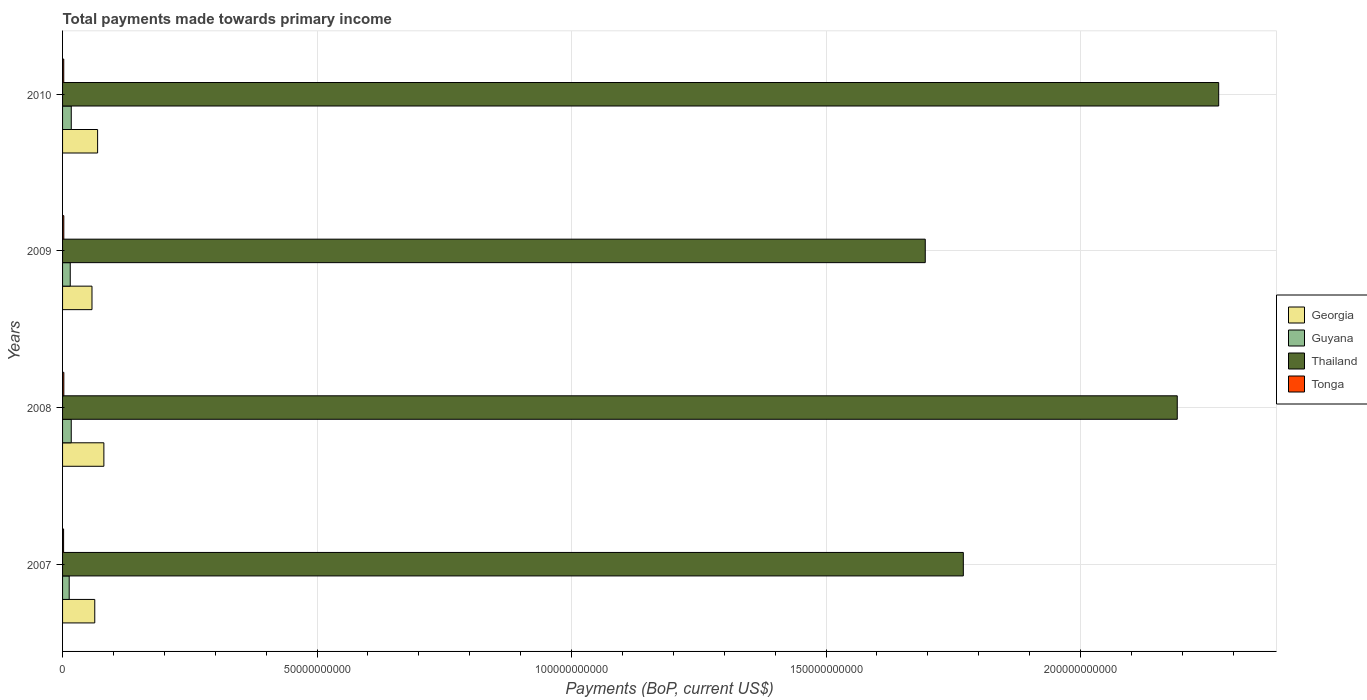How many different coloured bars are there?
Provide a short and direct response. 4. How many bars are there on the 1st tick from the top?
Make the answer very short. 4. How many bars are there on the 4th tick from the bottom?
Your response must be concise. 4. What is the label of the 4th group of bars from the top?
Give a very brief answer. 2007. What is the total payments made towards primary income in Tonga in 2010?
Your response must be concise. 2.33e+08. Across all years, what is the maximum total payments made towards primary income in Guyana?
Offer a very short reply. 1.71e+09. Across all years, what is the minimum total payments made towards primary income in Georgia?
Provide a short and direct response. 5.78e+09. What is the total total payments made towards primary income in Guyana in the graph?
Make the answer very short. 6.23e+09. What is the difference between the total payments made towards primary income in Georgia in 2007 and that in 2009?
Make the answer very short. 5.46e+08. What is the difference between the total payments made towards primary income in Guyana in 2009 and the total payments made towards primary income in Thailand in 2007?
Make the answer very short. -1.75e+11. What is the average total payments made towards primary income in Georgia per year?
Your answer should be compact. 6.78e+09. In the year 2009, what is the difference between the total payments made towards primary income in Guyana and total payments made towards primary income in Thailand?
Offer a terse response. -1.68e+11. In how many years, is the total payments made towards primary income in Thailand greater than 200000000000 US$?
Your answer should be compact. 2. What is the ratio of the total payments made towards primary income in Guyana in 2009 to that in 2010?
Ensure brevity in your answer.  0.88. What is the difference between the highest and the second highest total payments made towards primary income in Tonga?
Offer a very short reply. 5.78e+06. What is the difference between the highest and the lowest total payments made towards primary income in Guyana?
Offer a very short reply. 4.06e+08. What does the 1st bar from the top in 2007 represents?
Your answer should be compact. Tonga. What does the 1st bar from the bottom in 2009 represents?
Keep it short and to the point. Georgia. Is it the case that in every year, the sum of the total payments made towards primary income in Guyana and total payments made towards primary income in Tonga is greater than the total payments made towards primary income in Georgia?
Keep it short and to the point. No. How many bars are there?
Keep it short and to the point. 16. How many years are there in the graph?
Your response must be concise. 4. What is the difference between two consecutive major ticks on the X-axis?
Your response must be concise. 5.00e+1. Are the values on the major ticks of X-axis written in scientific E-notation?
Offer a very short reply. No. Does the graph contain any zero values?
Provide a succinct answer. No. Does the graph contain grids?
Your response must be concise. Yes. How many legend labels are there?
Your response must be concise. 4. How are the legend labels stacked?
Provide a succinct answer. Vertical. What is the title of the graph?
Make the answer very short. Total payments made towards primary income. What is the label or title of the X-axis?
Ensure brevity in your answer.  Payments (BoP, current US$). What is the label or title of the Y-axis?
Offer a very short reply. Years. What is the Payments (BoP, current US$) in Georgia in 2007?
Your answer should be very brief. 6.32e+09. What is the Payments (BoP, current US$) of Guyana in 2007?
Make the answer very short. 1.30e+09. What is the Payments (BoP, current US$) of Thailand in 2007?
Provide a short and direct response. 1.77e+11. What is the Payments (BoP, current US$) in Tonga in 2007?
Your answer should be very brief. 2.03e+08. What is the Payments (BoP, current US$) of Georgia in 2008?
Make the answer very short. 8.11e+09. What is the Payments (BoP, current US$) in Guyana in 2008?
Your response must be concise. 1.70e+09. What is the Payments (BoP, current US$) in Thailand in 2008?
Ensure brevity in your answer.  2.19e+11. What is the Payments (BoP, current US$) in Tonga in 2008?
Make the answer very short. 2.51e+08. What is the Payments (BoP, current US$) in Georgia in 2009?
Your response must be concise. 5.78e+09. What is the Payments (BoP, current US$) of Guyana in 2009?
Your response must be concise. 1.51e+09. What is the Payments (BoP, current US$) in Thailand in 2009?
Your answer should be compact. 1.69e+11. What is the Payments (BoP, current US$) of Tonga in 2009?
Ensure brevity in your answer.  2.45e+08. What is the Payments (BoP, current US$) of Georgia in 2010?
Your answer should be very brief. 6.89e+09. What is the Payments (BoP, current US$) in Guyana in 2010?
Make the answer very short. 1.71e+09. What is the Payments (BoP, current US$) in Thailand in 2010?
Ensure brevity in your answer.  2.27e+11. What is the Payments (BoP, current US$) of Tonga in 2010?
Keep it short and to the point. 2.33e+08. Across all years, what is the maximum Payments (BoP, current US$) of Georgia?
Your answer should be very brief. 8.11e+09. Across all years, what is the maximum Payments (BoP, current US$) in Guyana?
Offer a terse response. 1.71e+09. Across all years, what is the maximum Payments (BoP, current US$) of Thailand?
Offer a very short reply. 2.27e+11. Across all years, what is the maximum Payments (BoP, current US$) in Tonga?
Offer a very short reply. 2.51e+08. Across all years, what is the minimum Payments (BoP, current US$) in Georgia?
Give a very brief answer. 5.78e+09. Across all years, what is the minimum Payments (BoP, current US$) of Guyana?
Offer a very short reply. 1.30e+09. Across all years, what is the minimum Payments (BoP, current US$) of Thailand?
Make the answer very short. 1.69e+11. Across all years, what is the minimum Payments (BoP, current US$) of Tonga?
Your answer should be very brief. 2.03e+08. What is the total Payments (BoP, current US$) in Georgia in the graph?
Ensure brevity in your answer.  2.71e+1. What is the total Payments (BoP, current US$) in Guyana in the graph?
Give a very brief answer. 6.23e+09. What is the total Payments (BoP, current US$) of Thailand in the graph?
Make the answer very short. 7.93e+11. What is the total Payments (BoP, current US$) of Tonga in the graph?
Your response must be concise. 9.32e+08. What is the difference between the Payments (BoP, current US$) in Georgia in 2007 and that in 2008?
Give a very brief answer. -1.79e+09. What is the difference between the Payments (BoP, current US$) of Guyana in 2007 and that in 2008?
Your response must be concise. -4.02e+08. What is the difference between the Payments (BoP, current US$) in Thailand in 2007 and that in 2008?
Provide a short and direct response. -4.20e+1. What is the difference between the Payments (BoP, current US$) of Tonga in 2007 and that in 2008?
Provide a succinct answer. -4.80e+07. What is the difference between the Payments (BoP, current US$) of Georgia in 2007 and that in 2009?
Give a very brief answer. 5.46e+08. What is the difference between the Payments (BoP, current US$) of Guyana in 2007 and that in 2009?
Keep it short and to the point. -2.05e+08. What is the difference between the Payments (BoP, current US$) of Thailand in 2007 and that in 2009?
Ensure brevity in your answer.  7.48e+09. What is the difference between the Payments (BoP, current US$) of Tonga in 2007 and that in 2009?
Keep it short and to the point. -4.23e+07. What is the difference between the Payments (BoP, current US$) of Georgia in 2007 and that in 2010?
Keep it short and to the point. -5.60e+08. What is the difference between the Payments (BoP, current US$) of Guyana in 2007 and that in 2010?
Give a very brief answer. -4.06e+08. What is the difference between the Payments (BoP, current US$) of Thailand in 2007 and that in 2010?
Ensure brevity in your answer.  -5.02e+1. What is the difference between the Payments (BoP, current US$) in Tonga in 2007 and that in 2010?
Provide a succinct answer. -2.95e+07. What is the difference between the Payments (BoP, current US$) of Georgia in 2008 and that in 2009?
Your response must be concise. 2.34e+09. What is the difference between the Payments (BoP, current US$) in Guyana in 2008 and that in 2009?
Your answer should be very brief. 1.96e+08. What is the difference between the Payments (BoP, current US$) in Thailand in 2008 and that in 2009?
Provide a short and direct response. 4.95e+1. What is the difference between the Payments (BoP, current US$) of Tonga in 2008 and that in 2009?
Offer a terse response. 5.78e+06. What is the difference between the Payments (BoP, current US$) of Georgia in 2008 and that in 2010?
Keep it short and to the point. 1.23e+09. What is the difference between the Payments (BoP, current US$) in Guyana in 2008 and that in 2010?
Offer a very short reply. -3.92e+06. What is the difference between the Payments (BoP, current US$) in Thailand in 2008 and that in 2010?
Your response must be concise. -8.14e+09. What is the difference between the Payments (BoP, current US$) in Tonga in 2008 and that in 2010?
Your response must be concise. 1.86e+07. What is the difference between the Payments (BoP, current US$) of Georgia in 2009 and that in 2010?
Keep it short and to the point. -1.11e+09. What is the difference between the Payments (BoP, current US$) of Guyana in 2009 and that in 2010?
Provide a short and direct response. -2.00e+08. What is the difference between the Payments (BoP, current US$) of Thailand in 2009 and that in 2010?
Provide a short and direct response. -5.76e+1. What is the difference between the Payments (BoP, current US$) in Tonga in 2009 and that in 2010?
Your response must be concise. 1.28e+07. What is the difference between the Payments (BoP, current US$) of Georgia in 2007 and the Payments (BoP, current US$) of Guyana in 2008?
Offer a terse response. 4.62e+09. What is the difference between the Payments (BoP, current US$) in Georgia in 2007 and the Payments (BoP, current US$) in Thailand in 2008?
Your answer should be very brief. -2.13e+11. What is the difference between the Payments (BoP, current US$) in Georgia in 2007 and the Payments (BoP, current US$) in Tonga in 2008?
Give a very brief answer. 6.07e+09. What is the difference between the Payments (BoP, current US$) of Guyana in 2007 and the Payments (BoP, current US$) of Thailand in 2008?
Your response must be concise. -2.18e+11. What is the difference between the Payments (BoP, current US$) in Guyana in 2007 and the Payments (BoP, current US$) in Tonga in 2008?
Provide a succinct answer. 1.05e+09. What is the difference between the Payments (BoP, current US$) of Thailand in 2007 and the Payments (BoP, current US$) of Tonga in 2008?
Offer a terse response. 1.77e+11. What is the difference between the Payments (BoP, current US$) of Georgia in 2007 and the Payments (BoP, current US$) of Guyana in 2009?
Ensure brevity in your answer.  4.82e+09. What is the difference between the Payments (BoP, current US$) in Georgia in 2007 and the Payments (BoP, current US$) in Thailand in 2009?
Provide a short and direct response. -1.63e+11. What is the difference between the Payments (BoP, current US$) of Georgia in 2007 and the Payments (BoP, current US$) of Tonga in 2009?
Your answer should be very brief. 6.08e+09. What is the difference between the Payments (BoP, current US$) in Guyana in 2007 and the Payments (BoP, current US$) in Thailand in 2009?
Offer a very short reply. -1.68e+11. What is the difference between the Payments (BoP, current US$) in Guyana in 2007 and the Payments (BoP, current US$) in Tonga in 2009?
Your answer should be very brief. 1.06e+09. What is the difference between the Payments (BoP, current US$) in Thailand in 2007 and the Payments (BoP, current US$) in Tonga in 2009?
Make the answer very short. 1.77e+11. What is the difference between the Payments (BoP, current US$) of Georgia in 2007 and the Payments (BoP, current US$) of Guyana in 2010?
Ensure brevity in your answer.  4.62e+09. What is the difference between the Payments (BoP, current US$) of Georgia in 2007 and the Payments (BoP, current US$) of Thailand in 2010?
Make the answer very short. -2.21e+11. What is the difference between the Payments (BoP, current US$) in Georgia in 2007 and the Payments (BoP, current US$) in Tonga in 2010?
Provide a succinct answer. 6.09e+09. What is the difference between the Payments (BoP, current US$) of Guyana in 2007 and the Payments (BoP, current US$) of Thailand in 2010?
Offer a terse response. -2.26e+11. What is the difference between the Payments (BoP, current US$) of Guyana in 2007 and the Payments (BoP, current US$) of Tonga in 2010?
Make the answer very short. 1.07e+09. What is the difference between the Payments (BoP, current US$) of Thailand in 2007 and the Payments (BoP, current US$) of Tonga in 2010?
Provide a succinct answer. 1.77e+11. What is the difference between the Payments (BoP, current US$) in Georgia in 2008 and the Payments (BoP, current US$) in Guyana in 2009?
Provide a short and direct response. 6.61e+09. What is the difference between the Payments (BoP, current US$) of Georgia in 2008 and the Payments (BoP, current US$) of Thailand in 2009?
Offer a terse response. -1.61e+11. What is the difference between the Payments (BoP, current US$) of Georgia in 2008 and the Payments (BoP, current US$) of Tonga in 2009?
Ensure brevity in your answer.  7.87e+09. What is the difference between the Payments (BoP, current US$) in Guyana in 2008 and the Payments (BoP, current US$) in Thailand in 2009?
Keep it short and to the point. -1.68e+11. What is the difference between the Payments (BoP, current US$) in Guyana in 2008 and the Payments (BoP, current US$) in Tonga in 2009?
Give a very brief answer. 1.46e+09. What is the difference between the Payments (BoP, current US$) of Thailand in 2008 and the Payments (BoP, current US$) of Tonga in 2009?
Offer a very short reply. 2.19e+11. What is the difference between the Payments (BoP, current US$) in Georgia in 2008 and the Payments (BoP, current US$) in Guyana in 2010?
Your answer should be very brief. 6.41e+09. What is the difference between the Payments (BoP, current US$) of Georgia in 2008 and the Payments (BoP, current US$) of Thailand in 2010?
Provide a short and direct response. -2.19e+11. What is the difference between the Payments (BoP, current US$) of Georgia in 2008 and the Payments (BoP, current US$) of Tonga in 2010?
Your answer should be very brief. 7.88e+09. What is the difference between the Payments (BoP, current US$) in Guyana in 2008 and the Payments (BoP, current US$) in Thailand in 2010?
Keep it short and to the point. -2.25e+11. What is the difference between the Payments (BoP, current US$) of Guyana in 2008 and the Payments (BoP, current US$) of Tonga in 2010?
Provide a short and direct response. 1.47e+09. What is the difference between the Payments (BoP, current US$) of Thailand in 2008 and the Payments (BoP, current US$) of Tonga in 2010?
Ensure brevity in your answer.  2.19e+11. What is the difference between the Payments (BoP, current US$) of Georgia in 2009 and the Payments (BoP, current US$) of Guyana in 2010?
Offer a terse response. 4.07e+09. What is the difference between the Payments (BoP, current US$) of Georgia in 2009 and the Payments (BoP, current US$) of Thailand in 2010?
Provide a short and direct response. -2.21e+11. What is the difference between the Payments (BoP, current US$) in Georgia in 2009 and the Payments (BoP, current US$) in Tonga in 2010?
Offer a very short reply. 5.55e+09. What is the difference between the Payments (BoP, current US$) in Guyana in 2009 and the Payments (BoP, current US$) in Thailand in 2010?
Make the answer very short. -2.26e+11. What is the difference between the Payments (BoP, current US$) in Guyana in 2009 and the Payments (BoP, current US$) in Tonga in 2010?
Your answer should be very brief. 1.28e+09. What is the difference between the Payments (BoP, current US$) of Thailand in 2009 and the Payments (BoP, current US$) of Tonga in 2010?
Make the answer very short. 1.69e+11. What is the average Payments (BoP, current US$) of Georgia per year?
Your answer should be compact. 6.78e+09. What is the average Payments (BoP, current US$) of Guyana per year?
Provide a short and direct response. 1.56e+09. What is the average Payments (BoP, current US$) of Thailand per year?
Provide a short and direct response. 1.98e+11. What is the average Payments (BoP, current US$) in Tonga per year?
Your answer should be compact. 2.33e+08. In the year 2007, what is the difference between the Payments (BoP, current US$) of Georgia and Payments (BoP, current US$) of Guyana?
Your response must be concise. 5.02e+09. In the year 2007, what is the difference between the Payments (BoP, current US$) of Georgia and Payments (BoP, current US$) of Thailand?
Make the answer very short. -1.71e+11. In the year 2007, what is the difference between the Payments (BoP, current US$) of Georgia and Payments (BoP, current US$) of Tonga?
Ensure brevity in your answer.  6.12e+09. In the year 2007, what is the difference between the Payments (BoP, current US$) in Guyana and Payments (BoP, current US$) in Thailand?
Provide a succinct answer. -1.76e+11. In the year 2007, what is the difference between the Payments (BoP, current US$) in Guyana and Payments (BoP, current US$) in Tonga?
Your response must be concise. 1.10e+09. In the year 2007, what is the difference between the Payments (BoP, current US$) of Thailand and Payments (BoP, current US$) of Tonga?
Your response must be concise. 1.77e+11. In the year 2008, what is the difference between the Payments (BoP, current US$) of Georgia and Payments (BoP, current US$) of Guyana?
Ensure brevity in your answer.  6.41e+09. In the year 2008, what is the difference between the Payments (BoP, current US$) of Georgia and Payments (BoP, current US$) of Thailand?
Your answer should be compact. -2.11e+11. In the year 2008, what is the difference between the Payments (BoP, current US$) in Georgia and Payments (BoP, current US$) in Tonga?
Your response must be concise. 7.86e+09. In the year 2008, what is the difference between the Payments (BoP, current US$) of Guyana and Payments (BoP, current US$) of Thailand?
Provide a succinct answer. -2.17e+11. In the year 2008, what is the difference between the Payments (BoP, current US$) of Guyana and Payments (BoP, current US$) of Tonga?
Provide a short and direct response. 1.45e+09. In the year 2008, what is the difference between the Payments (BoP, current US$) in Thailand and Payments (BoP, current US$) in Tonga?
Offer a terse response. 2.19e+11. In the year 2009, what is the difference between the Payments (BoP, current US$) of Georgia and Payments (BoP, current US$) of Guyana?
Your response must be concise. 4.27e+09. In the year 2009, what is the difference between the Payments (BoP, current US$) in Georgia and Payments (BoP, current US$) in Thailand?
Your response must be concise. -1.64e+11. In the year 2009, what is the difference between the Payments (BoP, current US$) of Georgia and Payments (BoP, current US$) of Tonga?
Your response must be concise. 5.53e+09. In the year 2009, what is the difference between the Payments (BoP, current US$) of Guyana and Payments (BoP, current US$) of Thailand?
Offer a terse response. -1.68e+11. In the year 2009, what is the difference between the Payments (BoP, current US$) in Guyana and Payments (BoP, current US$) in Tonga?
Your response must be concise. 1.26e+09. In the year 2009, what is the difference between the Payments (BoP, current US$) in Thailand and Payments (BoP, current US$) in Tonga?
Provide a short and direct response. 1.69e+11. In the year 2010, what is the difference between the Payments (BoP, current US$) in Georgia and Payments (BoP, current US$) in Guyana?
Keep it short and to the point. 5.18e+09. In the year 2010, what is the difference between the Payments (BoP, current US$) of Georgia and Payments (BoP, current US$) of Thailand?
Ensure brevity in your answer.  -2.20e+11. In the year 2010, what is the difference between the Payments (BoP, current US$) of Georgia and Payments (BoP, current US$) of Tonga?
Provide a short and direct response. 6.65e+09. In the year 2010, what is the difference between the Payments (BoP, current US$) of Guyana and Payments (BoP, current US$) of Thailand?
Make the answer very short. -2.25e+11. In the year 2010, what is the difference between the Payments (BoP, current US$) of Guyana and Payments (BoP, current US$) of Tonga?
Offer a terse response. 1.48e+09. In the year 2010, what is the difference between the Payments (BoP, current US$) of Thailand and Payments (BoP, current US$) of Tonga?
Your response must be concise. 2.27e+11. What is the ratio of the Payments (BoP, current US$) of Georgia in 2007 to that in 2008?
Offer a very short reply. 0.78. What is the ratio of the Payments (BoP, current US$) in Guyana in 2007 to that in 2008?
Your answer should be very brief. 0.76. What is the ratio of the Payments (BoP, current US$) of Thailand in 2007 to that in 2008?
Offer a very short reply. 0.81. What is the ratio of the Payments (BoP, current US$) of Tonga in 2007 to that in 2008?
Your answer should be very brief. 0.81. What is the ratio of the Payments (BoP, current US$) in Georgia in 2007 to that in 2009?
Offer a terse response. 1.09. What is the ratio of the Payments (BoP, current US$) of Guyana in 2007 to that in 2009?
Offer a terse response. 0.86. What is the ratio of the Payments (BoP, current US$) in Thailand in 2007 to that in 2009?
Keep it short and to the point. 1.04. What is the ratio of the Payments (BoP, current US$) in Tonga in 2007 to that in 2009?
Your answer should be compact. 0.83. What is the ratio of the Payments (BoP, current US$) of Georgia in 2007 to that in 2010?
Offer a very short reply. 0.92. What is the ratio of the Payments (BoP, current US$) of Guyana in 2007 to that in 2010?
Your response must be concise. 0.76. What is the ratio of the Payments (BoP, current US$) of Thailand in 2007 to that in 2010?
Provide a short and direct response. 0.78. What is the ratio of the Payments (BoP, current US$) of Tonga in 2007 to that in 2010?
Keep it short and to the point. 0.87. What is the ratio of the Payments (BoP, current US$) in Georgia in 2008 to that in 2009?
Your answer should be compact. 1.4. What is the ratio of the Payments (BoP, current US$) of Guyana in 2008 to that in 2009?
Ensure brevity in your answer.  1.13. What is the ratio of the Payments (BoP, current US$) in Thailand in 2008 to that in 2009?
Offer a very short reply. 1.29. What is the ratio of the Payments (BoP, current US$) of Tonga in 2008 to that in 2009?
Offer a terse response. 1.02. What is the ratio of the Payments (BoP, current US$) of Georgia in 2008 to that in 2010?
Provide a short and direct response. 1.18. What is the ratio of the Payments (BoP, current US$) of Guyana in 2008 to that in 2010?
Ensure brevity in your answer.  1. What is the ratio of the Payments (BoP, current US$) of Thailand in 2008 to that in 2010?
Your answer should be compact. 0.96. What is the ratio of the Payments (BoP, current US$) in Tonga in 2008 to that in 2010?
Provide a short and direct response. 1.08. What is the ratio of the Payments (BoP, current US$) in Georgia in 2009 to that in 2010?
Offer a terse response. 0.84. What is the ratio of the Payments (BoP, current US$) in Guyana in 2009 to that in 2010?
Provide a succinct answer. 0.88. What is the ratio of the Payments (BoP, current US$) in Thailand in 2009 to that in 2010?
Your response must be concise. 0.75. What is the ratio of the Payments (BoP, current US$) of Tonga in 2009 to that in 2010?
Offer a very short reply. 1.05. What is the difference between the highest and the second highest Payments (BoP, current US$) of Georgia?
Give a very brief answer. 1.23e+09. What is the difference between the highest and the second highest Payments (BoP, current US$) in Guyana?
Your answer should be very brief. 3.92e+06. What is the difference between the highest and the second highest Payments (BoP, current US$) of Thailand?
Your answer should be very brief. 8.14e+09. What is the difference between the highest and the second highest Payments (BoP, current US$) in Tonga?
Your answer should be compact. 5.78e+06. What is the difference between the highest and the lowest Payments (BoP, current US$) of Georgia?
Your answer should be very brief. 2.34e+09. What is the difference between the highest and the lowest Payments (BoP, current US$) of Guyana?
Give a very brief answer. 4.06e+08. What is the difference between the highest and the lowest Payments (BoP, current US$) in Thailand?
Keep it short and to the point. 5.76e+1. What is the difference between the highest and the lowest Payments (BoP, current US$) of Tonga?
Your answer should be very brief. 4.80e+07. 